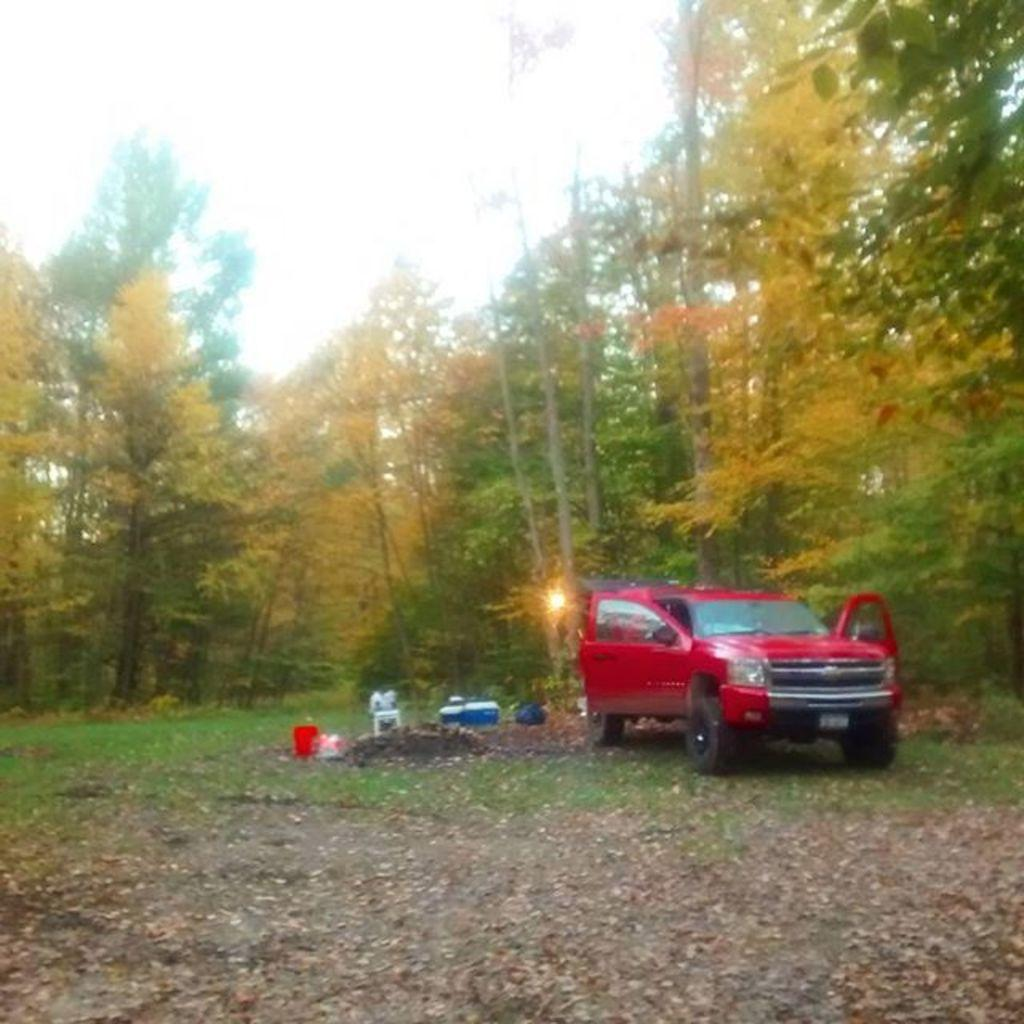What color is the vehicle in the image? The vehicle in the image is red. What is the state of the vehicle's doors? The vehicle's doors are open. What can be seen in the background of the image? There are trees in the background of the image. What else is visible in the image besides the vehicle? There are objects visible in the image. Can you describe the lighting in the image? There is light in the image. How does the baby show interest in the cable in the image? There is no baby or cable present in the image. 